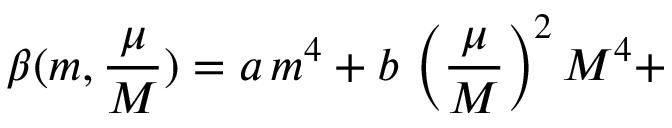Convert formula to latex. <formula><loc_0><loc_0><loc_500><loc_500>\beta ( m , \frac { \mu } { M } ) = a \, m ^ { 4 } + b \, \left ( \frac { \mu } { M } \right ) ^ { 2 } M ^ { 4 } +</formula> 